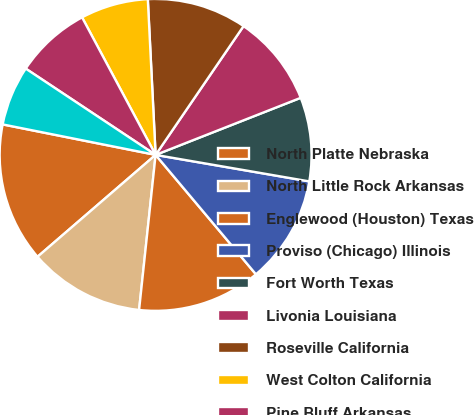<chart> <loc_0><loc_0><loc_500><loc_500><pie_chart><fcel>North Platte Nebraska<fcel>North Little Rock Arkansas<fcel>Englewood (Houston) Texas<fcel>Proviso (Chicago) Illinois<fcel>Fort Worth Texas<fcel>Livonia Louisiana<fcel>Roseville California<fcel>West Colton California<fcel>Pine Bluff Arkansas<fcel>Neff (Kansas City) Missouri<nl><fcel>14.46%<fcel>11.98%<fcel>12.81%<fcel>11.16%<fcel>8.68%<fcel>9.5%<fcel>10.33%<fcel>7.02%<fcel>7.85%<fcel>6.2%<nl></chart> 